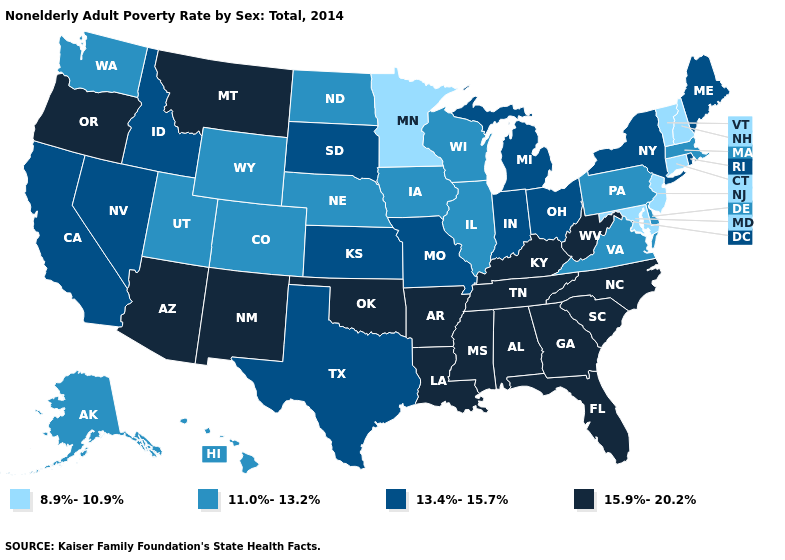Does the first symbol in the legend represent the smallest category?
Quick response, please. Yes. Does Iowa have the same value as Virginia?
Quick response, please. Yes. Name the states that have a value in the range 11.0%-13.2%?
Keep it brief. Alaska, Colorado, Delaware, Hawaii, Illinois, Iowa, Massachusetts, Nebraska, North Dakota, Pennsylvania, Utah, Virginia, Washington, Wisconsin, Wyoming. What is the value of Kansas?
Answer briefly. 13.4%-15.7%. Does Illinois have the same value as South Dakota?
Quick response, please. No. Name the states that have a value in the range 8.9%-10.9%?
Write a very short answer. Connecticut, Maryland, Minnesota, New Hampshire, New Jersey, Vermont. What is the value of Rhode Island?
Keep it brief. 13.4%-15.7%. Name the states that have a value in the range 11.0%-13.2%?
Answer briefly. Alaska, Colorado, Delaware, Hawaii, Illinois, Iowa, Massachusetts, Nebraska, North Dakota, Pennsylvania, Utah, Virginia, Washington, Wisconsin, Wyoming. Which states have the lowest value in the West?
Give a very brief answer. Alaska, Colorado, Hawaii, Utah, Washington, Wyoming. Does Louisiana have the same value as New Hampshire?
Concise answer only. No. What is the value of Iowa?
Give a very brief answer. 11.0%-13.2%. Does Idaho have the lowest value in the West?
Be succinct. No. Does the map have missing data?
Give a very brief answer. No. Which states have the highest value in the USA?
Quick response, please. Alabama, Arizona, Arkansas, Florida, Georgia, Kentucky, Louisiana, Mississippi, Montana, New Mexico, North Carolina, Oklahoma, Oregon, South Carolina, Tennessee, West Virginia. Which states have the lowest value in the USA?
Be succinct. Connecticut, Maryland, Minnesota, New Hampshire, New Jersey, Vermont. 